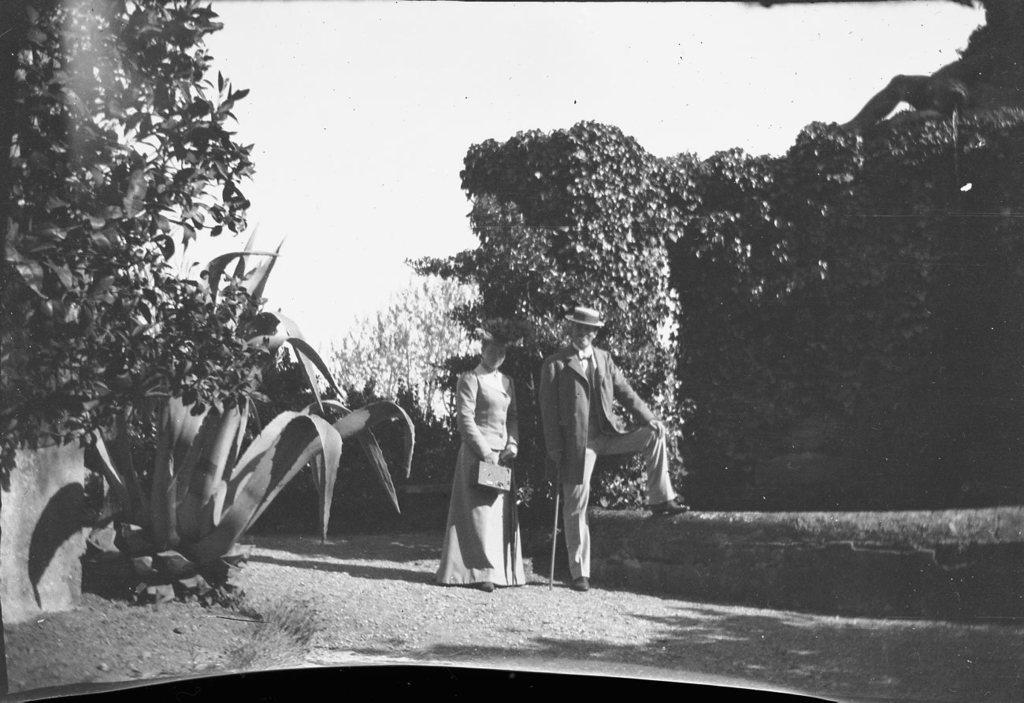How would you summarize this image in a sentence or two? In this image there is an old photograph of a couple standing and posing for the camera with a smile on their face, around the couple there are trees. 